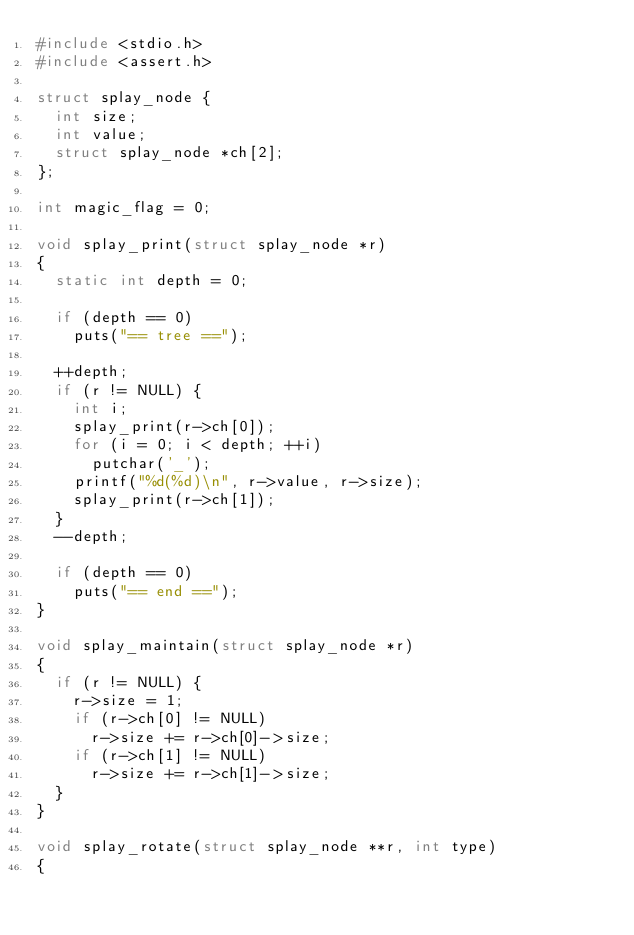Convert code to text. <code><loc_0><loc_0><loc_500><loc_500><_C_>#include <stdio.h>
#include <assert.h>

struct splay_node {
	int size;
	int value;
	struct splay_node *ch[2];
};

int magic_flag = 0;

void splay_print(struct splay_node *r)
{
	static int depth = 0;

	if (depth == 0)
		puts("== tree ==");

	++depth;
	if (r != NULL) {
		int i;
		splay_print(r->ch[0]);
		for (i = 0; i < depth; ++i)
			putchar('_');
		printf("%d(%d)\n", r->value, r->size);
		splay_print(r->ch[1]);
	}
	--depth;

	if (depth == 0)
		puts("== end ==");
}

void splay_maintain(struct splay_node *r)
{
	if (r != NULL) {
		r->size = 1;
		if (r->ch[0] != NULL)
			r->size += r->ch[0]->size;
		if (r->ch[1] != NULL)
			r->size += r->ch[1]->size;
	}
}

void splay_rotate(struct splay_node **r, int type)
{</code> 